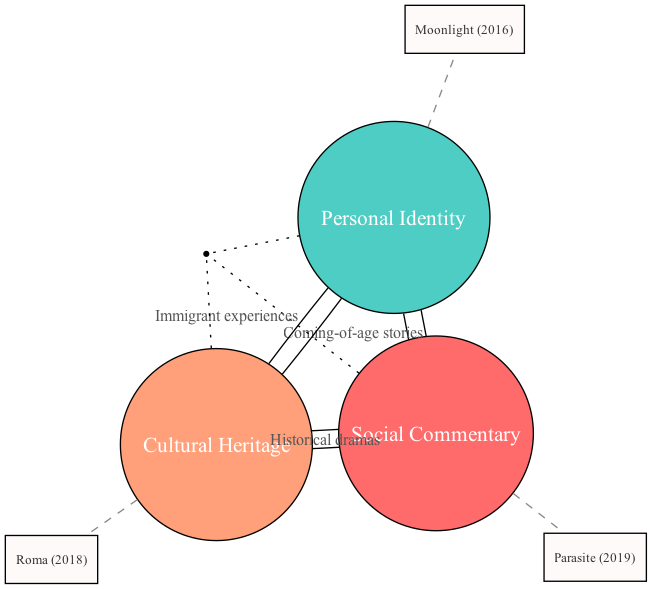What are the three main themes represented in the diagram? The diagram shows three main themes: Social Commentary, Personal Identity, and Cultural Heritage. These themes are clearly labeled as sets.
Answer: Social Commentary, Personal Identity, Cultural Heritage Which film is associated with the intersection of Social Commentary and Personal Identity? The diagram indicates that the film associated with the intersection of these two themes is labeled as "Coming-of-age stories." This is represented as an intersection label within the diagram.
Answer: Coming-of-age stories How many notable films are shown in the diagram? The diagram identifies three notable films, each linked to one of the themes: "Parasite (2019)" for Social Commentary, "Moonlight (2016)" for Personal Identity, and "Roma (2018)" for Cultural Heritage.
Answer: 3 Which film is uniquely located at the intersection of all three themes? According to the diagram, the film that lies at the intersection of Social Commentary, Personal Identity, and Cultural Heritage is specifically labeled as "Nomadland (2020)." This is highlighted in the area where all three themes overlap.
Answer: Nomadland (2020) What is the connection between Cultural Heritage and Personal Identity in the diagram? The diagram shows that Cultural Heritage and Personal Identity intersect through the label "Immigrant experiences," indicating a thematic relationship between the two sets.
Answer: Immigrant experiences Which theme does "Parasite (2019)" belong to? The diagram clearly labels "Parasite (2019)" under the theme of Social Commentary, indicating its classification according to the thematic focus shown in the diagram.
Answer: Social Commentary 